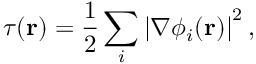Convert formula to latex. <formula><loc_0><loc_0><loc_500><loc_500>\tau ( r ) = \frac { 1 } { 2 } \sum _ { i } \left | \nabla \phi _ { i } ( r ) \right | ^ { 2 } ,</formula> 